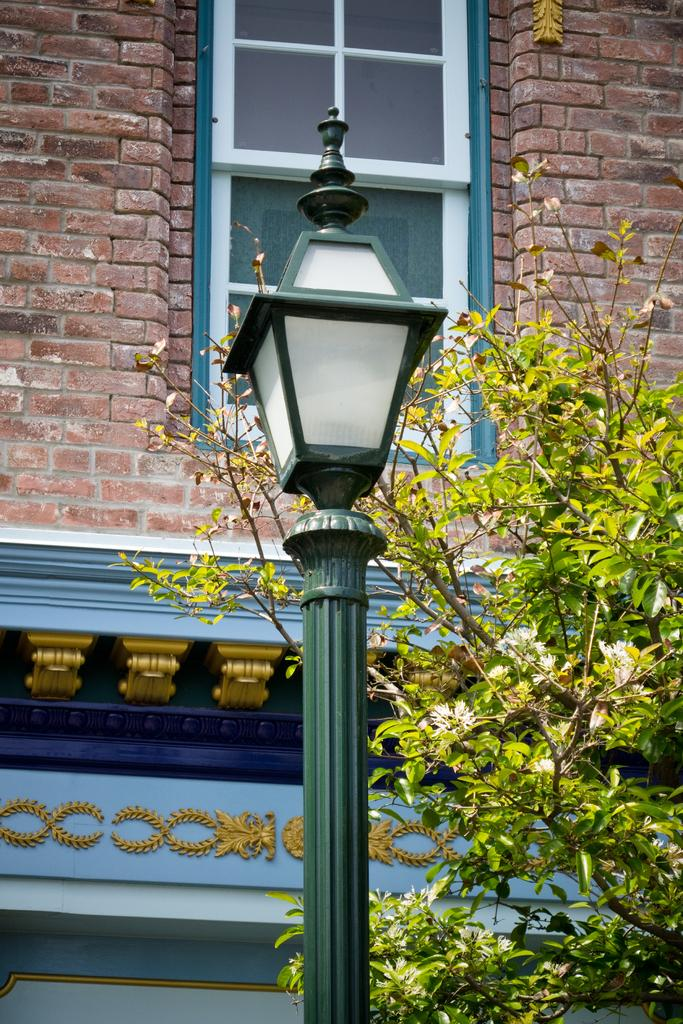What is the main object in the center of the image? There is a light in the center of the image. What can be seen in the background of the image? There is a tree and a window visible on a building in the background. What type of breakfast is being served on the land in the image? There is no land or breakfast present in the image; it features a light in the center and a tree and window in the background. 